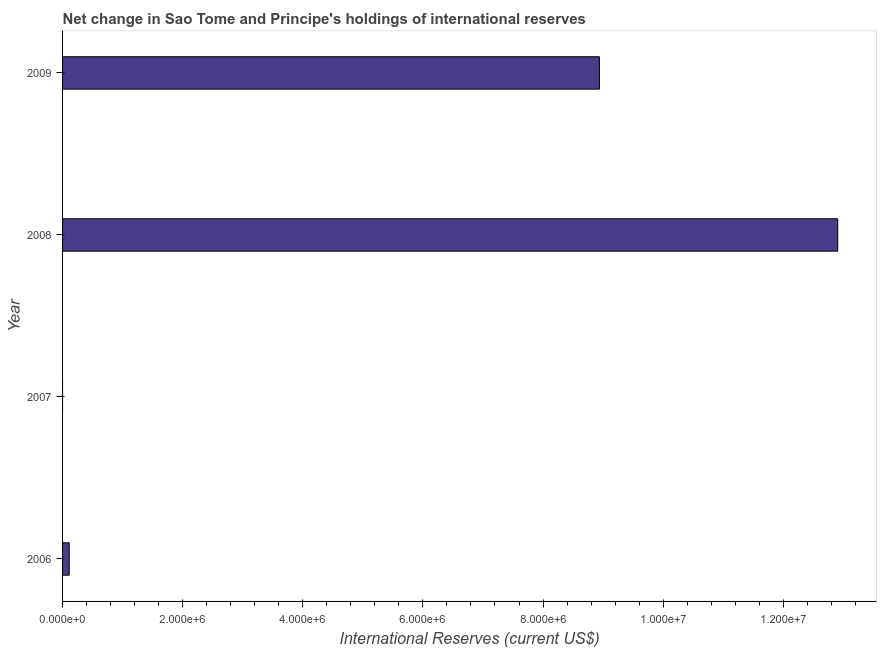Does the graph contain any zero values?
Offer a terse response. Yes. What is the title of the graph?
Your answer should be very brief. Net change in Sao Tome and Principe's holdings of international reserves. What is the label or title of the X-axis?
Your answer should be compact. International Reserves (current US$). What is the reserves and related items in 2007?
Ensure brevity in your answer.  0. Across all years, what is the maximum reserves and related items?
Your answer should be very brief. 1.29e+07. Across all years, what is the minimum reserves and related items?
Provide a short and direct response. 0. What is the sum of the reserves and related items?
Make the answer very short. 2.20e+07. What is the difference between the reserves and related items in 2006 and 2009?
Provide a short and direct response. -8.83e+06. What is the average reserves and related items per year?
Make the answer very short. 5.49e+06. What is the median reserves and related items?
Provide a short and direct response. 4.52e+06. In how many years, is the reserves and related items greater than 2400000 US$?
Make the answer very short. 2. What is the ratio of the reserves and related items in 2006 to that in 2008?
Provide a short and direct response. 0.01. Is the reserves and related items in 2006 less than that in 2008?
Make the answer very short. Yes. What is the difference between the highest and the second highest reserves and related items?
Provide a short and direct response. 3.97e+06. What is the difference between the highest and the lowest reserves and related items?
Your answer should be very brief. 1.29e+07. How many bars are there?
Give a very brief answer. 3. How many years are there in the graph?
Offer a terse response. 4. What is the difference between two consecutive major ticks on the X-axis?
Offer a terse response. 2.00e+06. Are the values on the major ticks of X-axis written in scientific E-notation?
Your answer should be very brief. Yes. What is the International Reserves (current US$) of 2006?
Offer a very short reply. 1.11e+05. What is the International Reserves (current US$) of 2008?
Provide a short and direct response. 1.29e+07. What is the International Reserves (current US$) in 2009?
Offer a terse response. 8.94e+06. What is the difference between the International Reserves (current US$) in 2006 and 2008?
Offer a very short reply. -1.28e+07. What is the difference between the International Reserves (current US$) in 2006 and 2009?
Your answer should be very brief. -8.83e+06. What is the difference between the International Reserves (current US$) in 2008 and 2009?
Make the answer very short. 3.97e+06. What is the ratio of the International Reserves (current US$) in 2006 to that in 2008?
Make the answer very short. 0.01. What is the ratio of the International Reserves (current US$) in 2006 to that in 2009?
Your answer should be compact. 0.01. What is the ratio of the International Reserves (current US$) in 2008 to that in 2009?
Ensure brevity in your answer.  1.44. 